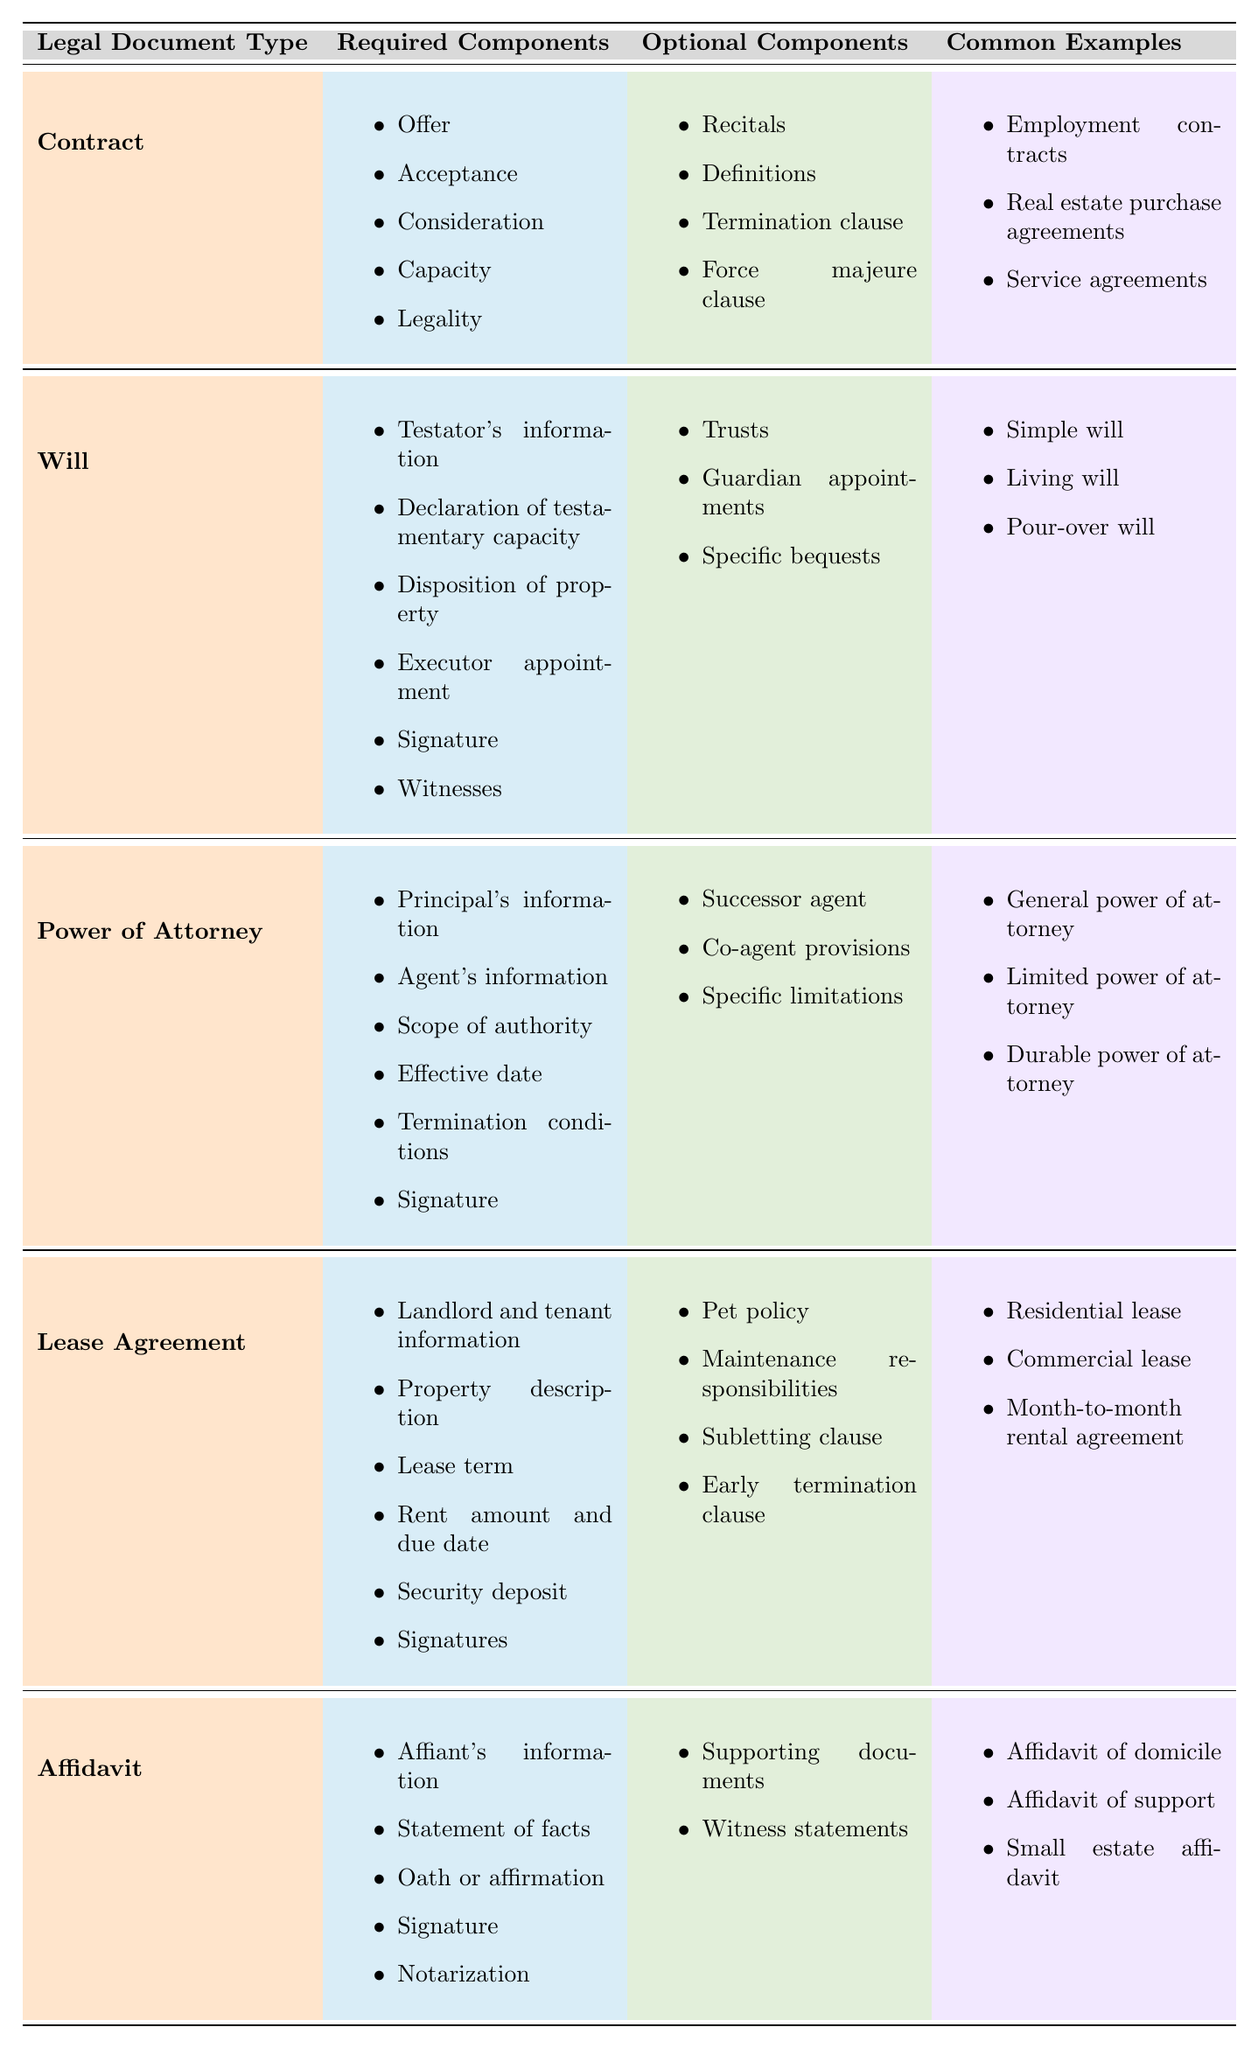What are the required components of a Will? The table lists six required components for a Will: Testator's information, Declaration of testamentary capacity, Disposition of property, Executor appointment, Signature, and Witnesses.
Answer: Testator's information, Declaration of testamentary capacity, Disposition of property, Executor appointment, Signature, Witnesses How many required components does a Lease Agreement have? By counting the items listed under the Lease Agreement in the table, there are six required components: Landlord and tenant information, Property description, Lease term, Rent amount and due date, Security deposit, and Signatures.
Answer: Six Does a Contract include a notarization component? Looking at the required components for a Contract, notarization is not listed among them. Therefore, the answer is no.
Answer: No Which legal document has a termination clause as an optional component? The table shows that a Contract and a Lease Agreement both have a termination clause listed under optional components. Therefore, either of these documents fits the criteria.
Answer: Contract and Lease Agreement What is the common example of a Durable Power of Attorney? The table lists three common examples under Power of Attorney: General power of attorney, Limited power of attorney, and Durable power of attorney. Therefore, Durable power of attorney is a common example itself.
Answer: Durable power of attorney How many total required components are there in a Power of Attorney? There are six required components listed for Power of Attorney: Principal's information, Agent's information, Scope of authority, Effective date, Termination conditions, and Signature. Thus, the total is six.
Answer: Six If you were to compare the optional components of Affidavit and Lease Agreement, which has more? The Affidavit has two optional components (Supporting documents, Witness statements), while the Lease Agreement has four (Pet policy, Maintenance responsibilities, Subletting clause, Early termination clause). Thus, the Lease Agreement has more optional components.
Answer: Lease Agreement Which legal document type requires witnesses to be valid? Upon reviewing the required components for the Will, it is noted that it requires witnesses for validity. No other legal document listed has this requirement.
Answer: Will Name one common example of a Simple Will. The table lists three types of common examples for Will, including Simple Will. So, a Simple Will itself is the common example.
Answer: Simple Will What is the total number of required components across all legal document types? To find the total, we can add the required components across all categories: 5 (Contract) + 6 (Will) + 6 (Power of Attorney) + 6 (Lease Agreement) + 5 (Affidavit) = 28.
Answer: 28 